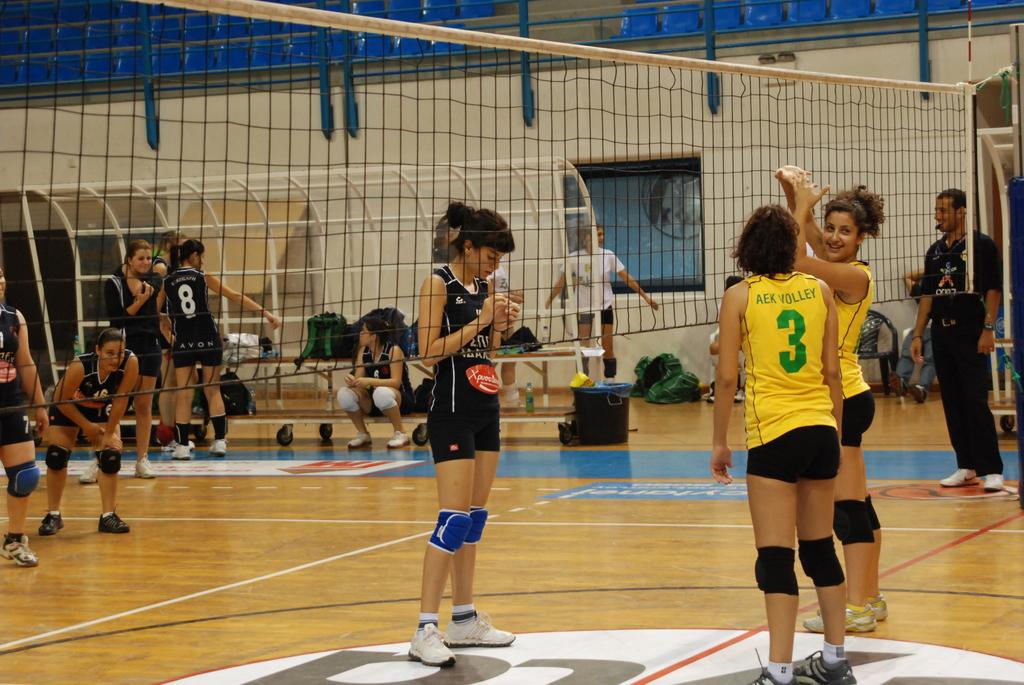What is the player number of the person wearing yellow who has their back turned?
Give a very brief answer. 3. What is written above the number 3 on the player's back?
Your response must be concise. Aek volley. 